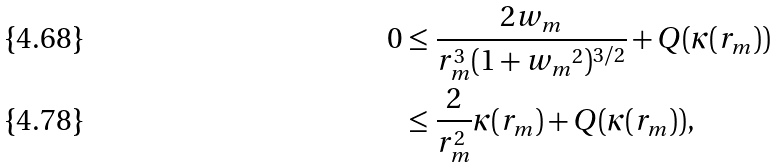Convert formula to latex. <formula><loc_0><loc_0><loc_500><loc_500>0 & \leq \frac { 2 w _ { m } } { r _ { m } ^ { 3 } ( 1 + { w _ { m } } ^ { 2 } ) ^ { 3 / 2 } } + Q ( \kappa ( r _ { m } ) ) \\ & \leq \frac { 2 } { r _ { m } ^ { 2 } } \kappa ( r _ { m } ) + Q ( \kappa ( r _ { m } ) ) ,</formula> 